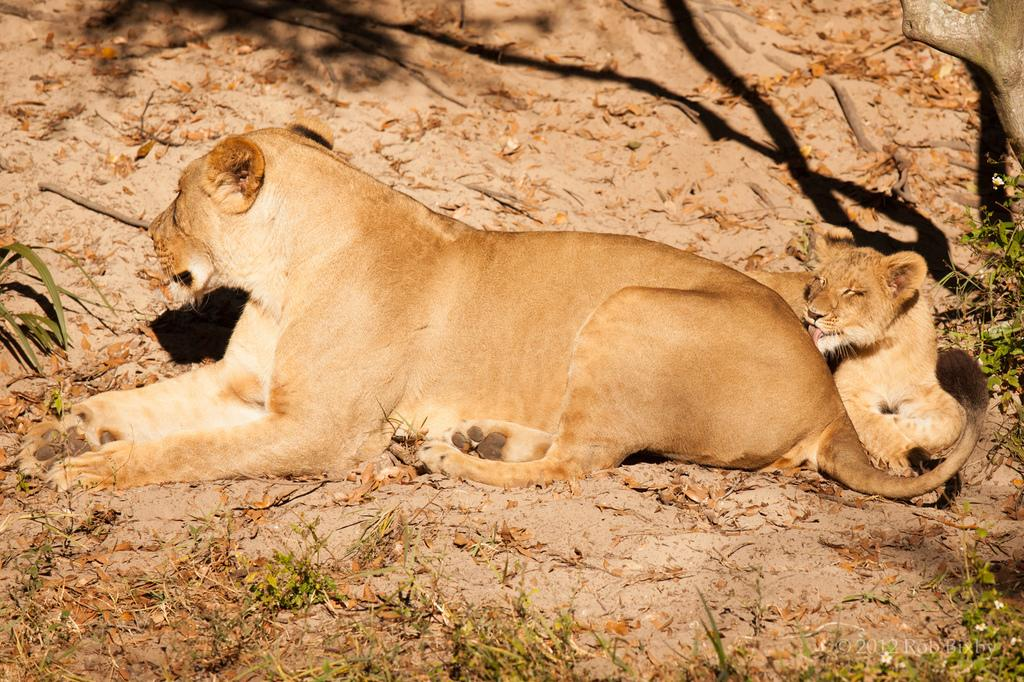What types of living organisms can be seen in the image? There are animals in the image. What can be found on the ground in the image? There are plants and leaves on the ground in the image. What structure is present in the image? There is a trunk in the image. What type of celery can be seen growing near the trunk in the image? There is no celery present in the image. How many frogs are sitting on the trunk in the image? There is no mention of frogs in the image, so we cannot determine their presence or quantity. 